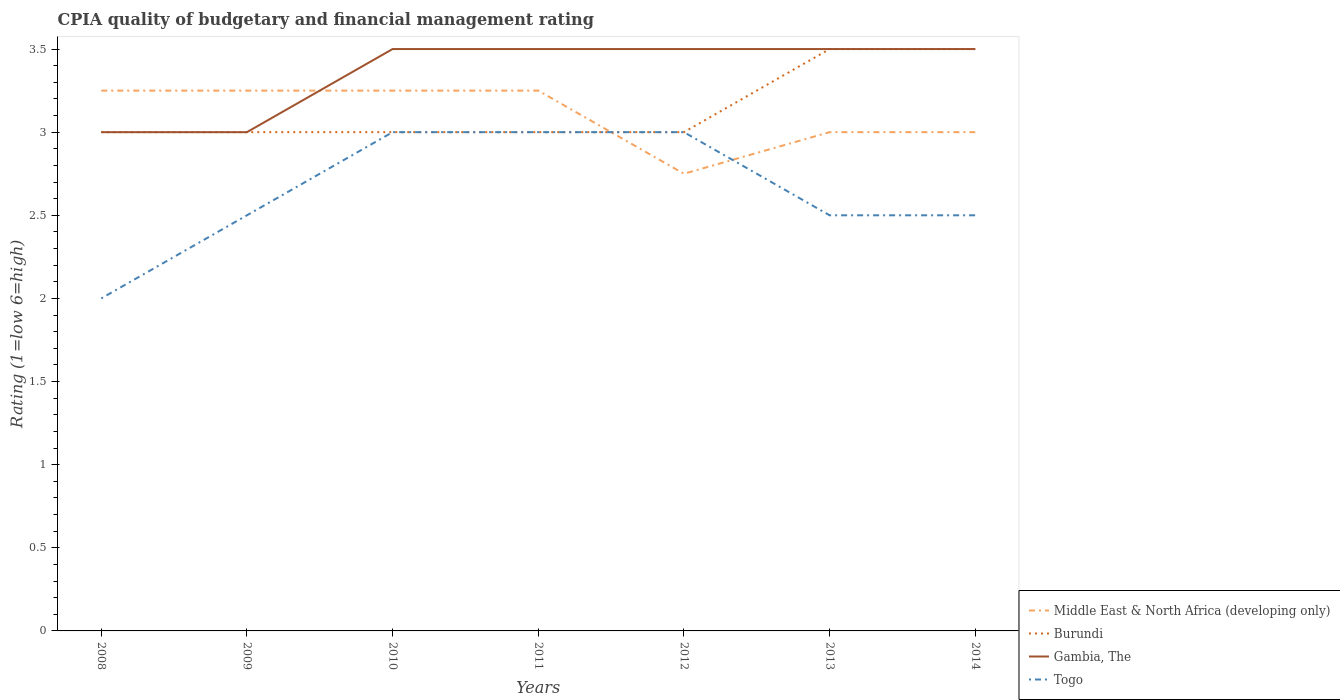Does the line corresponding to Middle East & North Africa (developing only) intersect with the line corresponding to Togo?
Your answer should be compact. Yes. Is the number of lines equal to the number of legend labels?
Ensure brevity in your answer.  Yes. Across all years, what is the maximum CPIA rating in Burundi?
Provide a succinct answer. 3. What is the total CPIA rating in Togo in the graph?
Make the answer very short. -0.5. What is the difference between the highest and the second highest CPIA rating in Togo?
Ensure brevity in your answer.  1. Is the CPIA rating in Togo strictly greater than the CPIA rating in Gambia, The over the years?
Make the answer very short. Yes. How many lines are there?
Offer a very short reply. 4. How many years are there in the graph?
Give a very brief answer. 7. Does the graph contain grids?
Provide a short and direct response. No. Where does the legend appear in the graph?
Make the answer very short. Bottom right. How many legend labels are there?
Your response must be concise. 4. How are the legend labels stacked?
Offer a terse response. Vertical. What is the title of the graph?
Offer a terse response. CPIA quality of budgetary and financial management rating. What is the Rating (1=low 6=high) in Burundi in 2008?
Offer a terse response. 3. What is the Rating (1=low 6=high) of Middle East & North Africa (developing only) in 2009?
Your answer should be very brief. 3.25. What is the Rating (1=low 6=high) in Burundi in 2009?
Provide a short and direct response. 3. What is the Rating (1=low 6=high) of Togo in 2009?
Offer a terse response. 2.5. What is the Rating (1=low 6=high) of Middle East & North Africa (developing only) in 2010?
Make the answer very short. 3.25. What is the Rating (1=low 6=high) of Gambia, The in 2010?
Offer a very short reply. 3.5. What is the Rating (1=low 6=high) in Middle East & North Africa (developing only) in 2011?
Keep it short and to the point. 3.25. What is the Rating (1=low 6=high) in Burundi in 2011?
Keep it short and to the point. 3. What is the Rating (1=low 6=high) in Middle East & North Africa (developing only) in 2012?
Keep it short and to the point. 2.75. What is the Rating (1=low 6=high) of Burundi in 2012?
Your response must be concise. 3. What is the Rating (1=low 6=high) in Gambia, The in 2012?
Your response must be concise. 3.5. What is the Rating (1=low 6=high) in Togo in 2012?
Provide a succinct answer. 3. What is the Rating (1=low 6=high) in Burundi in 2013?
Make the answer very short. 3.5. What is the Rating (1=low 6=high) of Togo in 2013?
Offer a terse response. 2.5. What is the Rating (1=low 6=high) of Middle East & North Africa (developing only) in 2014?
Ensure brevity in your answer.  3. What is the Rating (1=low 6=high) in Burundi in 2014?
Give a very brief answer. 3.5. Across all years, what is the maximum Rating (1=low 6=high) of Gambia, The?
Your answer should be compact. 3.5. Across all years, what is the minimum Rating (1=low 6=high) in Middle East & North Africa (developing only)?
Offer a very short reply. 2.75. Across all years, what is the minimum Rating (1=low 6=high) in Gambia, The?
Your answer should be very brief. 3. Across all years, what is the minimum Rating (1=low 6=high) in Togo?
Give a very brief answer. 2. What is the total Rating (1=low 6=high) of Middle East & North Africa (developing only) in the graph?
Ensure brevity in your answer.  21.75. What is the total Rating (1=low 6=high) in Burundi in the graph?
Your answer should be very brief. 22. What is the total Rating (1=low 6=high) of Togo in the graph?
Give a very brief answer. 18.5. What is the difference between the Rating (1=low 6=high) of Burundi in 2008 and that in 2009?
Offer a terse response. 0. What is the difference between the Rating (1=low 6=high) in Middle East & North Africa (developing only) in 2008 and that in 2010?
Offer a terse response. 0. What is the difference between the Rating (1=low 6=high) of Gambia, The in 2008 and that in 2010?
Provide a succinct answer. -0.5. What is the difference between the Rating (1=low 6=high) in Togo in 2008 and that in 2010?
Offer a very short reply. -1. What is the difference between the Rating (1=low 6=high) of Middle East & North Africa (developing only) in 2008 and that in 2011?
Provide a succinct answer. 0. What is the difference between the Rating (1=low 6=high) in Gambia, The in 2008 and that in 2011?
Keep it short and to the point. -0.5. What is the difference between the Rating (1=low 6=high) in Middle East & North Africa (developing only) in 2008 and that in 2012?
Your answer should be very brief. 0.5. What is the difference between the Rating (1=low 6=high) of Middle East & North Africa (developing only) in 2008 and that in 2013?
Offer a terse response. 0.25. What is the difference between the Rating (1=low 6=high) of Burundi in 2008 and that in 2013?
Provide a succinct answer. -0.5. What is the difference between the Rating (1=low 6=high) in Gambia, The in 2008 and that in 2013?
Give a very brief answer. -0.5. What is the difference between the Rating (1=low 6=high) of Burundi in 2008 and that in 2014?
Keep it short and to the point. -0.5. What is the difference between the Rating (1=low 6=high) of Gambia, The in 2008 and that in 2014?
Ensure brevity in your answer.  -0.5. What is the difference between the Rating (1=low 6=high) in Togo in 2008 and that in 2014?
Ensure brevity in your answer.  -0.5. What is the difference between the Rating (1=low 6=high) of Middle East & North Africa (developing only) in 2009 and that in 2010?
Make the answer very short. 0. What is the difference between the Rating (1=low 6=high) of Burundi in 2009 and that in 2010?
Keep it short and to the point. 0. What is the difference between the Rating (1=low 6=high) of Gambia, The in 2009 and that in 2010?
Provide a succinct answer. -0.5. What is the difference between the Rating (1=low 6=high) in Middle East & North Africa (developing only) in 2009 and that in 2011?
Offer a very short reply. 0. What is the difference between the Rating (1=low 6=high) in Togo in 2009 and that in 2011?
Offer a terse response. -0.5. What is the difference between the Rating (1=low 6=high) of Middle East & North Africa (developing only) in 2009 and that in 2012?
Your answer should be compact. 0.5. What is the difference between the Rating (1=low 6=high) in Burundi in 2009 and that in 2012?
Keep it short and to the point. 0. What is the difference between the Rating (1=low 6=high) in Burundi in 2009 and that in 2013?
Your answer should be compact. -0.5. What is the difference between the Rating (1=low 6=high) in Burundi in 2009 and that in 2014?
Make the answer very short. -0.5. What is the difference between the Rating (1=low 6=high) in Gambia, The in 2009 and that in 2014?
Your answer should be compact. -0.5. What is the difference between the Rating (1=low 6=high) in Middle East & North Africa (developing only) in 2010 and that in 2011?
Provide a short and direct response. 0. What is the difference between the Rating (1=low 6=high) of Burundi in 2010 and that in 2011?
Give a very brief answer. 0. What is the difference between the Rating (1=low 6=high) of Togo in 2010 and that in 2011?
Offer a terse response. 0. What is the difference between the Rating (1=low 6=high) in Burundi in 2010 and that in 2012?
Provide a short and direct response. 0. What is the difference between the Rating (1=low 6=high) of Gambia, The in 2010 and that in 2013?
Ensure brevity in your answer.  0. What is the difference between the Rating (1=low 6=high) of Togo in 2010 and that in 2013?
Give a very brief answer. 0.5. What is the difference between the Rating (1=low 6=high) of Middle East & North Africa (developing only) in 2010 and that in 2014?
Your response must be concise. 0.25. What is the difference between the Rating (1=low 6=high) of Togo in 2010 and that in 2014?
Offer a very short reply. 0.5. What is the difference between the Rating (1=low 6=high) in Middle East & North Africa (developing only) in 2011 and that in 2012?
Give a very brief answer. 0.5. What is the difference between the Rating (1=low 6=high) of Gambia, The in 2011 and that in 2012?
Offer a very short reply. 0. What is the difference between the Rating (1=low 6=high) of Togo in 2011 and that in 2012?
Offer a very short reply. 0. What is the difference between the Rating (1=low 6=high) in Burundi in 2011 and that in 2013?
Your answer should be compact. -0.5. What is the difference between the Rating (1=low 6=high) in Gambia, The in 2011 and that in 2013?
Offer a very short reply. 0. What is the difference between the Rating (1=low 6=high) in Burundi in 2011 and that in 2014?
Provide a succinct answer. -0.5. What is the difference between the Rating (1=low 6=high) of Togo in 2011 and that in 2014?
Provide a succinct answer. 0.5. What is the difference between the Rating (1=low 6=high) in Middle East & North Africa (developing only) in 2012 and that in 2014?
Offer a terse response. -0.25. What is the difference between the Rating (1=low 6=high) of Burundi in 2012 and that in 2014?
Your answer should be very brief. -0.5. What is the difference between the Rating (1=low 6=high) in Gambia, The in 2012 and that in 2014?
Offer a terse response. 0. What is the difference between the Rating (1=low 6=high) in Togo in 2012 and that in 2014?
Provide a short and direct response. 0.5. What is the difference between the Rating (1=low 6=high) of Middle East & North Africa (developing only) in 2013 and that in 2014?
Make the answer very short. 0. What is the difference between the Rating (1=low 6=high) in Gambia, The in 2013 and that in 2014?
Your answer should be very brief. 0. What is the difference between the Rating (1=low 6=high) in Togo in 2013 and that in 2014?
Offer a very short reply. 0. What is the difference between the Rating (1=low 6=high) of Middle East & North Africa (developing only) in 2008 and the Rating (1=low 6=high) of Burundi in 2009?
Provide a short and direct response. 0.25. What is the difference between the Rating (1=low 6=high) of Middle East & North Africa (developing only) in 2008 and the Rating (1=low 6=high) of Gambia, The in 2009?
Keep it short and to the point. 0.25. What is the difference between the Rating (1=low 6=high) in Burundi in 2008 and the Rating (1=low 6=high) in Gambia, The in 2009?
Give a very brief answer. 0. What is the difference between the Rating (1=low 6=high) of Burundi in 2008 and the Rating (1=low 6=high) of Togo in 2009?
Make the answer very short. 0.5. What is the difference between the Rating (1=low 6=high) in Middle East & North Africa (developing only) in 2008 and the Rating (1=low 6=high) in Burundi in 2010?
Offer a very short reply. 0.25. What is the difference between the Rating (1=low 6=high) of Middle East & North Africa (developing only) in 2008 and the Rating (1=low 6=high) of Gambia, The in 2010?
Your response must be concise. -0.25. What is the difference between the Rating (1=low 6=high) in Burundi in 2008 and the Rating (1=low 6=high) in Gambia, The in 2010?
Offer a very short reply. -0.5. What is the difference between the Rating (1=low 6=high) of Gambia, The in 2008 and the Rating (1=low 6=high) of Togo in 2010?
Provide a short and direct response. 0. What is the difference between the Rating (1=low 6=high) in Middle East & North Africa (developing only) in 2008 and the Rating (1=low 6=high) in Burundi in 2011?
Provide a short and direct response. 0.25. What is the difference between the Rating (1=low 6=high) of Gambia, The in 2008 and the Rating (1=low 6=high) of Togo in 2011?
Provide a short and direct response. 0. What is the difference between the Rating (1=low 6=high) of Middle East & North Africa (developing only) in 2008 and the Rating (1=low 6=high) of Togo in 2012?
Keep it short and to the point. 0.25. What is the difference between the Rating (1=low 6=high) in Burundi in 2008 and the Rating (1=low 6=high) in Togo in 2012?
Your response must be concise. 0. What is the difference between the Rating (1=low 6=high) of Middle East & North Africa (developing only) in 2008 and the Rating (1=low 6=high) of Togo in 2013?
Offer a terse response. 0.75. What is the difference between the Rating (1=low 6=high) in Burundi in 2008 and the Rating (1=low 6=high) in Gambia, The in 2013?
Offer a very short reply. -0.5. What is the difference between the Rating (1=low 6=high) in Burundi in 2008 and the Rating (1=low 6=high) in Togo in 2013?
Ensure brevity in your answer.  0.5. What is the difference between the Rating (1=low 6=high) in Gambia, The in 2008 and the Rating (1=low 6=high) in Togo in 2013?
Provide a succinct answer. 0.5. What is the difference between the Rating (1=low 6=high) of Middle East & North Africa (developing only) in 2008 and the Rating (1=low 6=high) of Gambia, The in 2014?
Your answer should be compact. -0.25. What is the difference between the Rating (1=low 6=high) in Burundi in 2008 and the Rating (1=low 6=high) in Gambia, The in 2014?
Give a very brief answer. -0.5. What is the difference between the Rating (1=low 6=high) in Burundi in 2008 and the Rating (1=low 6=high) in Togo in 2014?
Your response must be concise. 0.5. What is the difference between the Rating (1=low 6=high) in Gambia, The in 2008 and the Rating (1=low 6=high) in Togo in 2014?
Your answer should be compact. 0.5. What is the difference between the Rating (1=low 6=high) of Middle East & North Africa (developing only) in 2009 and the Rating (1=low 6=high) of Burundi in 2010?
Make the answer very short. 0.25. What is the difference between the Rating (1=low 6=high) of Middle East & North Africa (developing only) in 2009 and the Rating (1=low 6=high) of Togo in 2010?
Provide a short and direct response. 0.25. What is the difference between the Rating (1=low 6=high) in Gambia, The in 2009 and the Rating (1=low 6=high) in Togo in 2010?
Provide a short and direct response. 0. What is the difference between the Rating (1=low 6=high) in Burundi in 2009 and the Rating (1=low 6=high) in Gambia, The in 2011?
Ensure brevity in your answer.  -0.5. What is the difference between the Rating (1=low 6=high) of Burundi in 2009 and the Rating (1=low 6=high) of Togo in 2011?
Your response must be concise. 0. What is the difference between the Rating (1=low 6=high) in Gambia, The in 2009 and the Rating (1=low 6=high) in Togo in 2011?
Keep it short and to the point. 0. What is the difference between the Rating (1=low 6=high) in Middle East & North Africa (developing only) in 2009 and the Rating (1=low 6=high) in Burundi in 2012?
Ensure brevity in your answer.  0.25. What is the difference between the Rating (1=low 6=high) in Middle East & North Africa (developing only) in 2009 and the Rating (1=low 6=high) in Togo in 2012?
Keep it short and to the point. 0.25. What is the difference between the Rating (1=low 6=high) of Gambia, The in 2009 and the Rating (1=low 6=high) of Togo in 2012?
Your response must be concise. 0. What is the difference between the Rating (1=low 6=high) in Middle East & North Africa (developing only) in 2009 and the Rating (1=low 6=high) in Burundi in 2013?
Your answer should be compact. -0.25. What is the difference between the Rating (1=low 6=high) of Middle East & North Africa (developing only) in 2009 and the Rating (1=low 6=high) of Gambia, The in 2013?
Your answer should be compact. -0.25. What is the difference between the Rating (1=low 6=high) of Burundi in 2009 and the Rating (1=low 6=high) of Gambia, The in 2013?
Offer a very short reply. -0.5. What is the difference between the Rating (1=low 6=high) in Gambia, The in 2009 and the Rating (1=low 6=high) in Togo in 2013?
Keep it short and to the point. 0.5. What is the difference between the Rating (1=low 6=high) in Middle East & North Africa (developing only) in 2009 and the Rating (1=low 6=high) in Gambia, The in 2014?
Offer a very short reply. -0.25. What is the difference between the Rating (1=low 6=high) in Middle East & North Africa (developing only) in 2009 and the Rating (1=low 6=high) in Togo in 2014?
Make the answer very short. 0.75. What is the difference between the Rating (1=low 6=high) in Burundi in 2009 and the Rating (1=low 6=high) in Gambia, The in 2014?
Ensure brevity in your answer.  -0.5. What is the difference between the Rating (1=low 6=high) in Burundi in 2009 and the Rating (1=low 6=high) in Togo in 2014?
Offer a terse response. 0.5. What is the difference between the Rating (1=low 6=high) in Middle East & North Africa (developing only) in 2010 and the Rating (1=low 6=high) in Gambia, The in 2011?
Make the answer very short. -0.25. What is the difference between the Rating (1=low 6=high) of Burundi in 2010 and the Rating (1=low 6=high) of Gambia, The in 2011?
Provide a succinct answer. -0.5. What is the difference between the Rating (1=low 6=high) of Middle East & North Africa (developing only) in 2010 and the Rating (1=low 6=high) of Burundi in 2012?
Provide a short and direct response. 0.25. What is the difference between the Rating (1=low 6=high) of Middle East & North Africa (developing only) in 2010 and the Rating (1=low 6=high) of Gambia, The in 2012?
Make the answer very short. -0.25. What is the difference between the Rating (1=low 6=high) of Middle East & North Africa (developing only) in 2010 and the Rating (1=low 6=high) of Togo in 2012?
Provide a succinct answer. 0.25. What is the difference between the Rating (1=low 6=high) in Burundi in 2010 and the Rating (1=low 6=high) in Gambia, The in 2012?
Keep it short and to the point. -0.5. What is the difference between the Rating (1=low 6=high) of Gambia, The in 2010 and the Rating (1=low 6=high) of Togo in 2012?
Give a very brief answer. 0.5. What is the difference between the Rating (1=low 6=high) of Middle East & North Africa (developing only) in 2010 and the Rating (1=low 6=high) of Gambia, The in 2013?
Offer a terse response. -0.25. What is the difference between the Rating (1=low 6=high) of Middle East & North Africa (developing only) in 2010 and the Rating (1=low 6=high) of Togo in 2013?
Offer a very short reply. 0.75. What is the difference between the Rating (1=low 6=high) in Burundi in 2010 and the Rating (1=low 6=high) in Togo in 2013?
Provide a short and direct response. 0.5. What is the difference between the Rating (1=low 6=high) of Middle East & North Africa (developing only) in 2010 and the Rating (1=low 6=high) of Burundi in 2014?
Provide a short and direct response. -0.25. What is the difference between the Rating (1=low 6=high) of Middle East & North Africa (developing only) in 2010 and the Rating (1=low 6=high) of Gambia, The in 2014?
Offer a very short reply. -0.25. What is the difference between the Rating (1=low 6=high) of Burundi in 2010 and the Rating (1=low 6=high) of Togo in 2014?
Your response must be concise. 0.5. What is the difference between the Rating (1=low 6=high) in Middle East & North Africa (developing only) in 2011 and the Rating (1=low 6=high) in Burundi in 2012?
Provide a succinct answer. 0.25. What is the difference between the Rating (1=low 6=high) in Middle East & North Africa (developing only) in 2011 and the Rating (1=low 6=high) in Gambia, The in 2012?
Give a very brief answer. -0.25. What is the difference between the Rating (1=low 6=high) in Middle East & North Africa (developing only) in 2011 and the Rating (1=low 6=high) in Togo in 2012?
Your answer should be very brief. 0.25. What is the difference between the Rating (1=low 6=high) in Middle East & North Africa (developing only) in 2011 and the Rating (1=low 6=high) in Burundi in 2013?
Ensure brevity in your answer.  -0.25. What is the difference between the Rating (1=low 6=high) in Middle East & North Africa (developing only) in 2011 and the Rating (1=low 6=high) in Gambia, The in 2013?
Ensure brevity in your answer.  -0.25. What is the difference between the Rating (1=low 6=high) of Burundi in 2011 and the Rating (1=low 6=high) of Gambia, The in 2013?
Provide a short and direct response. -0.5. What is the difference between the Rating (1=low 6=high) of Middle East & North Africa (developing only) in 2011 and the Rating (1=low 6=high) of Gambia, The in 2014?
Offer a very short reply. -0.25. What is the difference between the Rating (1=low 6=high) of Burundi in 2011 and the Rating (1=low 6=high) of Togo in 2014?
Ensure brevity in your answer.  0.5. What is the difference between the Rating (1=low 6=high) of Gambia, The in 2011 and the Rating (1=low 6=high) of Togo in 2014?
Your response must be concise. 1. What is the difference between the Rating (1=low 6=high) in Middle East & North Africa (developing only) in 2012 and the Rating (1=low 6=high) in Burundi in 2013?
Offer a terse response. -0.75. What is the difference between the Rating (1=low 6=high) of Middle East & North Africa (developing only) in 2012 and the Rating (1=low 6=high) of Gambia, The in 2013?
Make the answer very short. -0.75. What is the difference between the Rating (1=low 6=high) of Burundi in 2012 and the Rating (1=low 6=high) of Gambia, The in 2013?
Make the answer very short. -0.5. What is the difference between the Rating (1=low 6=high) of Middle East & North Africa (developing only) in 2012 and the Rating (1=low 6=high) of Burundi in 2014?
Provide a short and direct response. -0.75. What is the difference between the Rating (1=low 6=high) in Middle East & North Africa (developing only) in 2012 and the Rating (1=low 6=high) in Gambia, The in 2014?
Ensure brevity in your answer.  -0.75. What is the difference between the Rating (1=low 6=high) in Burundi in 2012 and the Rating (1=low 6=high) in Gambia, The in 2014?
Keep it short and to the point. -0.5. What is the difference between the Rating (1=low 6=high) of Middle East & North Africa (developing only) in 2013 and the Rating (1=low 6=high) of Gambia, The in 2014?
Your answer should be very brief. -0.5. What is the difference between the Rating (1=low 6=high) of Middle East & North Africa (developing only) in 2013 and the Rating (1=low 6=high) of Togo in 2014?
Provide a short and direct response. 0.5. What is the difference between the Rating (1=low 6=high) of Burundi in 2013 and the Rating (1=low 6=high) of Gambia, The in 2014?
Offer a terse response. 0. What is the difference between the Rating (1=low 6=high) of Gambia, The in 2013 and the Rating (1=low 6=high) of Togo in 2014?
Give a very brief answer. 1. What is the average Rating (1=low 6=high) of Middle East & North Africa (developing only) per year?
Give a very brief answer. 3.11. What is the average Rating (1=low 6=high) of Burundi per year?
Ensure brevity in your answer.  3.14. What is the average Rating (1=low 6=high) in Gambia, The per year?
Provide a short and direct response. 3.36. What is the average Rating (1=low 6=high) in Togo per year?
Offer a very short reply. 2.64. In the year 2008, what is the difference between the Rating (1=low 6=high) of Middle East & North Africa (developing only) and Rating (1=low 6=high) of Burundi?
Your answer should be very brief. 0.25. In the year 2008, what is the difference between the Rating (1=low 6=high) in Middle East & North Africa (developing only) and Rating (1=low 6=high) in Gambia, The?
Your response must be concise. 0.25. In the year 2008, what is the difference between the Rating (1=low 6=high) of Middle East & North Africa (developing only) and Rating (1=low 6=high) of Togo?
Provide a short and direct response. 1.25. In the year 2008, what is the difference between the Rating (1=low 6=high) of Burundi and Rating (1=low 6=high) of Gambia, The?
Provide a short and direct response. 0. In the year 2009, what is the difference between the Rating (1=low 6=high) in Middle East & North Africa (developing only) and Rating (1=low 6=high) in Gambia, The?
Ensure brevity in your answer.  0.25. In the year 2009, what is the difference between the Rating (1=low 6=high) in Middle East & North Africa (developing only) and Rating (1=low 6=high) in Togo?
Provide a succinct answer. 0.75. In the year 2009, what is the difference between the Rating (1=low 6=high) of Burundi and Rating (1=low 6=high) of Togo?
Offer a terse response. 0.5. In the year 2010, what is the difference between the Rating (1=low 6=high) of Middle East & North Africa (developing only) and Rating (1=low 6=high) of Togo?
Offer a terse response. 0.25. In the year 2010, what is the difference between the Rating (1=low 6=high) in Gambia, The and Rating (1=low 6=high) in Togo?
Offer a very short reply. 0.5. In the year 2011, what is the difference between the Rating (1=low 6=high) in Middle East & North Africa (developing only) and Rating (1=low 6=high) in Gambia, The?
Provide a short and direct response. -0.25. In the year 2011, what is the difference between the Rating (1=low 6=high) in Burundi and Rating (1=low 6=high) in Gambia, The?
Your response must be concise. -0.5. In the year 2012, what is the difference between the Rating (1=low 6=high) of Middle East & North Africa (developing only) and Rating (1=low 6=high) of Burundi?
Give a very brief answer. -0.25. In the year 2012, what is the difference between the Rating (1=low 6=high) in Middle East & North Africa (developing only) and Rating (1=low 6=high) in Gambia, The?
Your answer should be very brief. -0.75. In the year 2012, what is the difference between the Rating (1=low 6=high) of Burundi and Rating (1=low 6=high) of Togo?
Keep it short and to the point. 0. In the year 2013, what is the difference between the Rating (1=low 6=high) of Middle East & North Africa (developing only) and Rating (1=low 6=high) of Burundi?
Your answer should be very brief. -0.5. In the year 2013, what is the difference between the Rating (1=low 6=high) of Middle East & North Africa (developing only) and Rating (1=low 6=high) of Gambia, The?
Your answer should be compact. -0.5. In the year 2013, what is the difference between the Rating (1=low 6=high) of Middle East & North Africa (developing only) and Rating (1=low 6=high) of Togo?
Provide a succinct answer. 0.5. In the year 2013, what is the difference between the Rating (1=low 6=high) in Burundi and Rating (1=low 6=high) in Gambia, The?
Offer a very short reply. 0. In the year 2013, what is the difference between the Rating (1=low 6=high) in Burundi and Rating (1=low 6=high) in Togo?
Make the answer very short. 1. In the year 2014, what is the difference between the Rating (1=low 6=high) of Middle East & North Africa (developing only) and Rating (1=low 6=high) of Burundi?
Give a very brief answer. -0.5. In the year 2014, what is the difference between the Rating (1=low 6=high) of Middle East & North Africa (developing only) and Rating (1=low 6=high) of Gambia, The?
Keep it short and to the point. -0.5. In the year 2014, what is the difference between the Rating (1=low 6=high) in Middle East & North Africa (developing only) and Rating (1=low 6=high) in Togo?
Give a very brief answer. 0.5. In the year 2014, what is the difference between the Rating (1=low 6=high) in Burundi and Rating (1=low 6=high) in Gambia, The?
Offer a terse response. 0. In the year 2014, what is the difference between the Rating (1=low 6=high) of Gambia, The and Rating (1=low 6=high) of Togo?
Offer a terse response. 1. What is the ratio of the Rating (1=low 6=high) in Middle East & North Africa (developing only) in 2008 to that in 2009?
Ensure brevity in your answer.  1. What is the ratio of the Rating (1=low 6=high) in Togo in 2008 to that in 2009?
Provide a short and direct response. 0.8. What is the ratio of the Rating (1=low 6=high) of Burundi in 2008 to that in 2010?
Your response must be concise. 1. What is the ratio of the Rating (1=low 6=high) in Gambia, The in 2008 to that in 2011?
Offer a terse response. 0.86. What is the ratio of the Rating (1=low 6=high) of Middle East & North Africa (developing only) in 2008 to that in 2012?
Offer a terse response. 1.18. What is the ratio of the Rating (1=low 6=high) of Burundi in 2008 to that in 2012?
Your answer should be compact. 1. What is the ratio of the Rating (1=low 6=high) of Togo in 2008 to that in 2012?
Your response must be concise. 0.67. What is the ratio of the Rating (1=low 6=high) of Middle East & North Africa (developing only) in 2008 to that in 2013?
Your response must be concise. 1.08. What is the ratio of the Rating (1=low 6=high) in Burundi in 2008 to that in 2014?
Your answer should be very brief. 0.86. What is the ratio of the Rating (1=low 6=high) in Gambia, The in 2008 to that in 2014?
Your answer should be very brief. 0.86. What is the ratio of the Rating (1=low 6=high) in Togo in 2008 to that in 2014?
Provide a succinct answer. 0.8. What is the ratio of the Rating (1=low 6=high) of Middle East & North Africa (developing only) in 2009 to that in 2011?
Provide a succinct answer. 1. What is the ratio of the Rating (1=low 6=high) of Burundi in 2009 to that in 2011?
Provide a short and direct response. 1. What is the ratio of the Rating (1=low 6=high) of Gambia, The in 2009 to that in 2011?
Provide a succinct answer. 0.86. What is the ratio of the Rating (1=low 6=high) of Middle East & North Africa (developing only) in 2009 to that in 2012?
Your answer should be compact. 1.18. What is the ratio of the Rating (1=low 6=high) in Gambia, The in 2009 to that in 2012?
Your response must be concise. 0.86. What is the ratio of the Rating (1=low 6=high) of Togo in 2009 to that in 2012?
Ensure brevity in your answer.  0.83. What is the ratio of the Rating (1=low 6=high) of Burundi in 2009 to that in 2013?
Your response must be concise. 0.86. What is the ratio of the Rating (1=low 6=high) of Burundi in 2010 to that in 2011?
Your response must be concise. 1. What is the ratio of the Rating (1=low 6=high) in Middle East & North Africa (developing only) in 2010 to that in 2012?
Provide a succinct answer. 1.18. What is the ratio of the Rating (1=low 6=high) in Burundi in 2010 to that in 2012?
Your response must be concise. 1. What is the ratio of the Rating (1=low 6=high) in Togo in 2010 to that in 2012?
Keep it short and to the point. 1. What is the ratio of the Rating (1=low 6=high) in Burundi in 2010 to that in 2013?
Your answer should be compact. 0.86. What is the ratio of the Rating (1=low 6=high) of Middle East & North Africa (developing only) in 2010 to that in 2014?
Provide a short and direct response. 1.08. What is the ratio of the Rating (1=low 6=high) of Gambia, The in 2010 to that in 2014?
Your answer should be compact. 1. What is the ratio of the Rating (1=low 6=high) in Middle East & North Africa (developing only) in 2011 to that in 2012?
Make the answer very short. 1.18. What is the ratio of the Rating (1=low 6=high) of Burundi in 2011 to that in 2012?
Ensure brevity in your answer.  1. What is the ratio of the Rating (1=low 6=high) of Burundi in 2011 to that in 2013?
Provide a short and direct response. 0.86. What is the ratio of the Rating (1=low 6=high) in Gambia, The in 2011 to that in 2013?
Provide a succinct answer. 1. What is the ratio of the Rating (1=low 6=high) of Burundi in 2011 to that in 2014?
Give a very brief answer. 0.86. What is the ratio of the Rating (1=low 6=high) in Togo in 2011 to that in 2014?
Offer a terse response. 1.2. What is the ratio of the Rating (1=low 6=high) in Middle East & North Africa (developing only) in 2012 to that in 2013?
Your answer should be very brief. 0.92. What is the ratio of the Rating (1=low 6=high) in Middle East & North Africa (developing only) in 2012 to that in 2014?
Give a very brief answer. 0.92. What is the ratio of the Rating (1=low 6=high) of Burundi in 2012 to that in 2014?
Provide a succinct answer. 0.86. What is the ratio of the Rating (1=low 6=high) of Togo in 2012 to that in 2014?
Give a very brief answer. 1.2. What is the ratio of the Rating (1=low 6=high) of Gambia, The in 2013 to that in 2014?
Offer a very short reply. 1. What is the ratio of the Rating (1=low 6=high) in Togo in 2013 to that in 2014?
Keep it short and to the point. 1. What is the difference between the highest and the second highest Rating (1=low 6=high) of Togo?
Keep it short and to the point. 0. What is the difference between the highest and the lowest Rating (1=low 6=high) of Middle East & North Africa (developing only)?
Ensure brevity in your answer.  0.5. What is the difference between the highest and the lowest Rating (1=low 6=high) of Burundi?
Give a very brief answer. 0.5. 